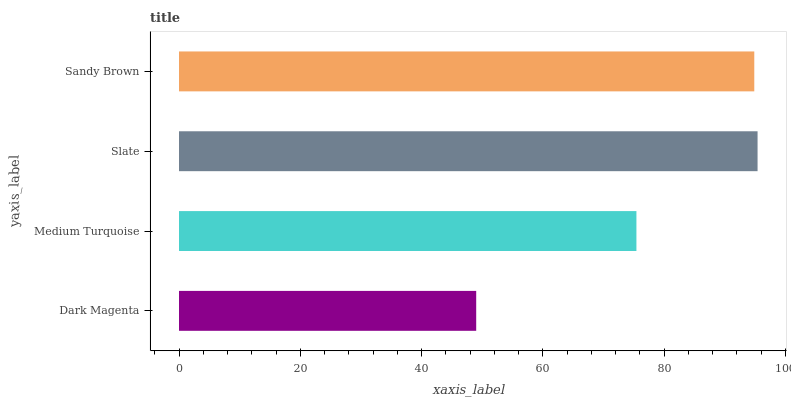Is Dark Magenta the minimum?
Answer yes or no. Yes. Is Slate the maximum?
Answer yes or no. Yes. Is Medium Turquoise the minimum?
Answer yes or no. No. Is Medium Turquoise the maximum?
Answer yes or no. No. Is Medium Turquoise greater than Dark Magenta?
Answer yes or no. Yes. Is Dark Magenta less than Medium Turquoise?
Answer yes or no. Yes. Is Dark Magenta greater than Medium Turquoise?
Answer yes or no. No. Is Medium Turquoise less than Dark Magenta?
Answer yes or no. No. Is Sandy Brown the high median?
Answer yes or no. Yes. Is Medium Turquoise the low median?
Answer yes or no. Yes. Is Slate the high median?
Answer yes or no. No. Is Dark Magenta the low median?
Answer yes or no. No. 